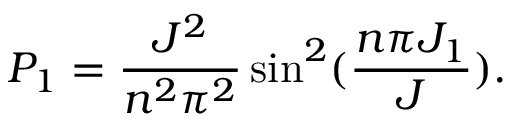<formula> <loc_0><loc_0><loc_500><loc_500>P _ { 1 } = \frac { J ^ { 2 } } { n ^ { 2 } \pi ^ { 2 } } \sin ^ { 2 } ( \frac { n \pi J _ { 1 } } { J } ) .</formula> 